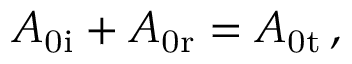<formula> <loc_0><loc_0><loc_500><loc_500>A _ { 0 i } + A _ { 0 r } = A _ { 0 t } \, ,</formula> 